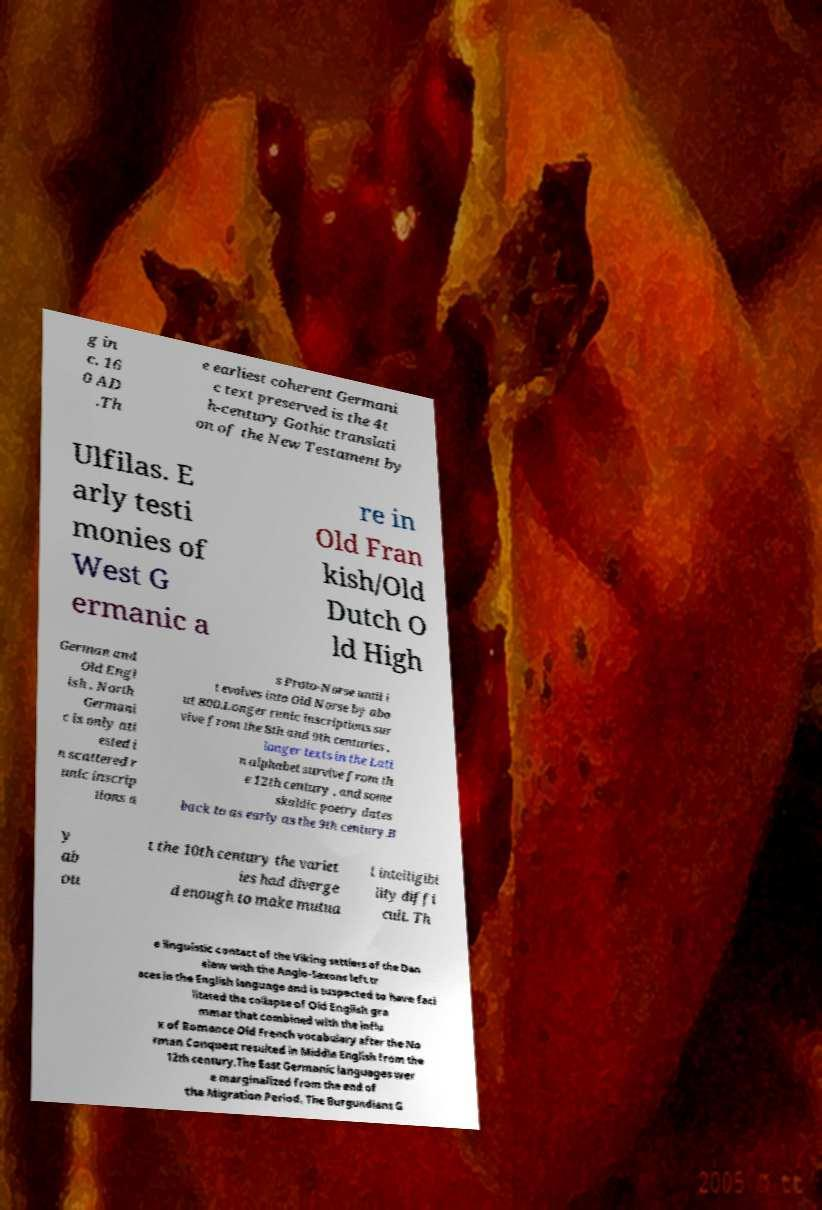Can you read and provide the text displayed in the image?This photo seems to have some interesting text. Can you extract and type it out for me? g in c. 16 0 AD .Th e earliest coherent Germani c text preserved is the 4t h-century Gothic translati on of the New Testament by Ulfilas. E arly testi monies of West G ermanic a re in Old Fran kish/Old Dutch O ld High German and Old Engl ish . North Germani c is only att ested i n scattered r unic inscrip tions a s Proto-Norse until i t evolves into Old Norse by abo ut 800.Longer runic inscriptions sur vive from the 8th and 9th centuries , longer texts in the Lati n alphabet survive from th e 12th century , and some skaldic poetry dates back to as early as the 9th century.B y ab ou t the 10th century the variet ies had diverge d enough to make mutua l intelligibi lity diffi cult. Th e linguistic contact of the Viking settlers of the Dan elaw with the Anglo-Saxons left tr aces in the English language and is suspected to have faci litated the collapse of Old English gra mmar that combined with the influ x of Romance Old French vocabulary after the No rman Conquest resulted in Middle English from the 12th century.The East Germanic languages wer e marginalized from the end of the Migration Period. The Burgundians G 